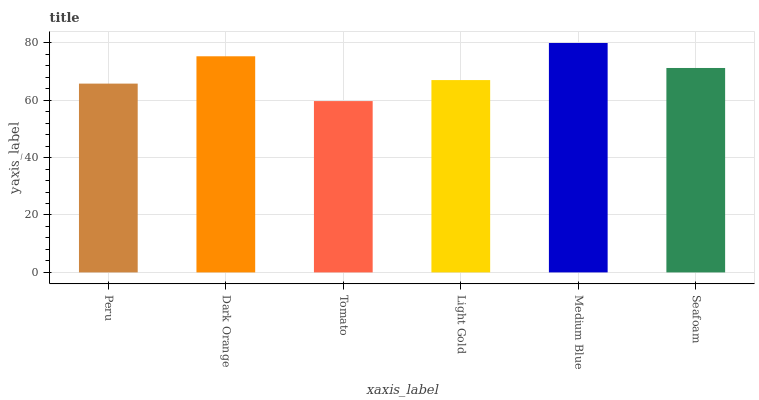Is Tomato the minimum?
Answer yes or no. Yes. Is Medium Blue the maximum?
Answer yes or no. Yes. Is Dark Orange the minimum?
Answer yes or no. No. Is Dark Orange the maximum?
Answer yes or no. No. Is Dark Orange greater than Peru?
Answer yes or no. Yes. Is Peru less than Dark Orange?
Answer yes or no. Yes. Is Peru greater than Dark Orange?
Answer yes or no. No. Is Dark Orange less than Peru?
Answer yes or no. No. Is Seafoam the high median?
Answer yes or no. Yes. Is Light Gold the low median?
Answer yes or no. Yes. Is Medium Blue the high median?
Answer yes or no. No. Is Tomato the low median?
Answer yes or no. No. 